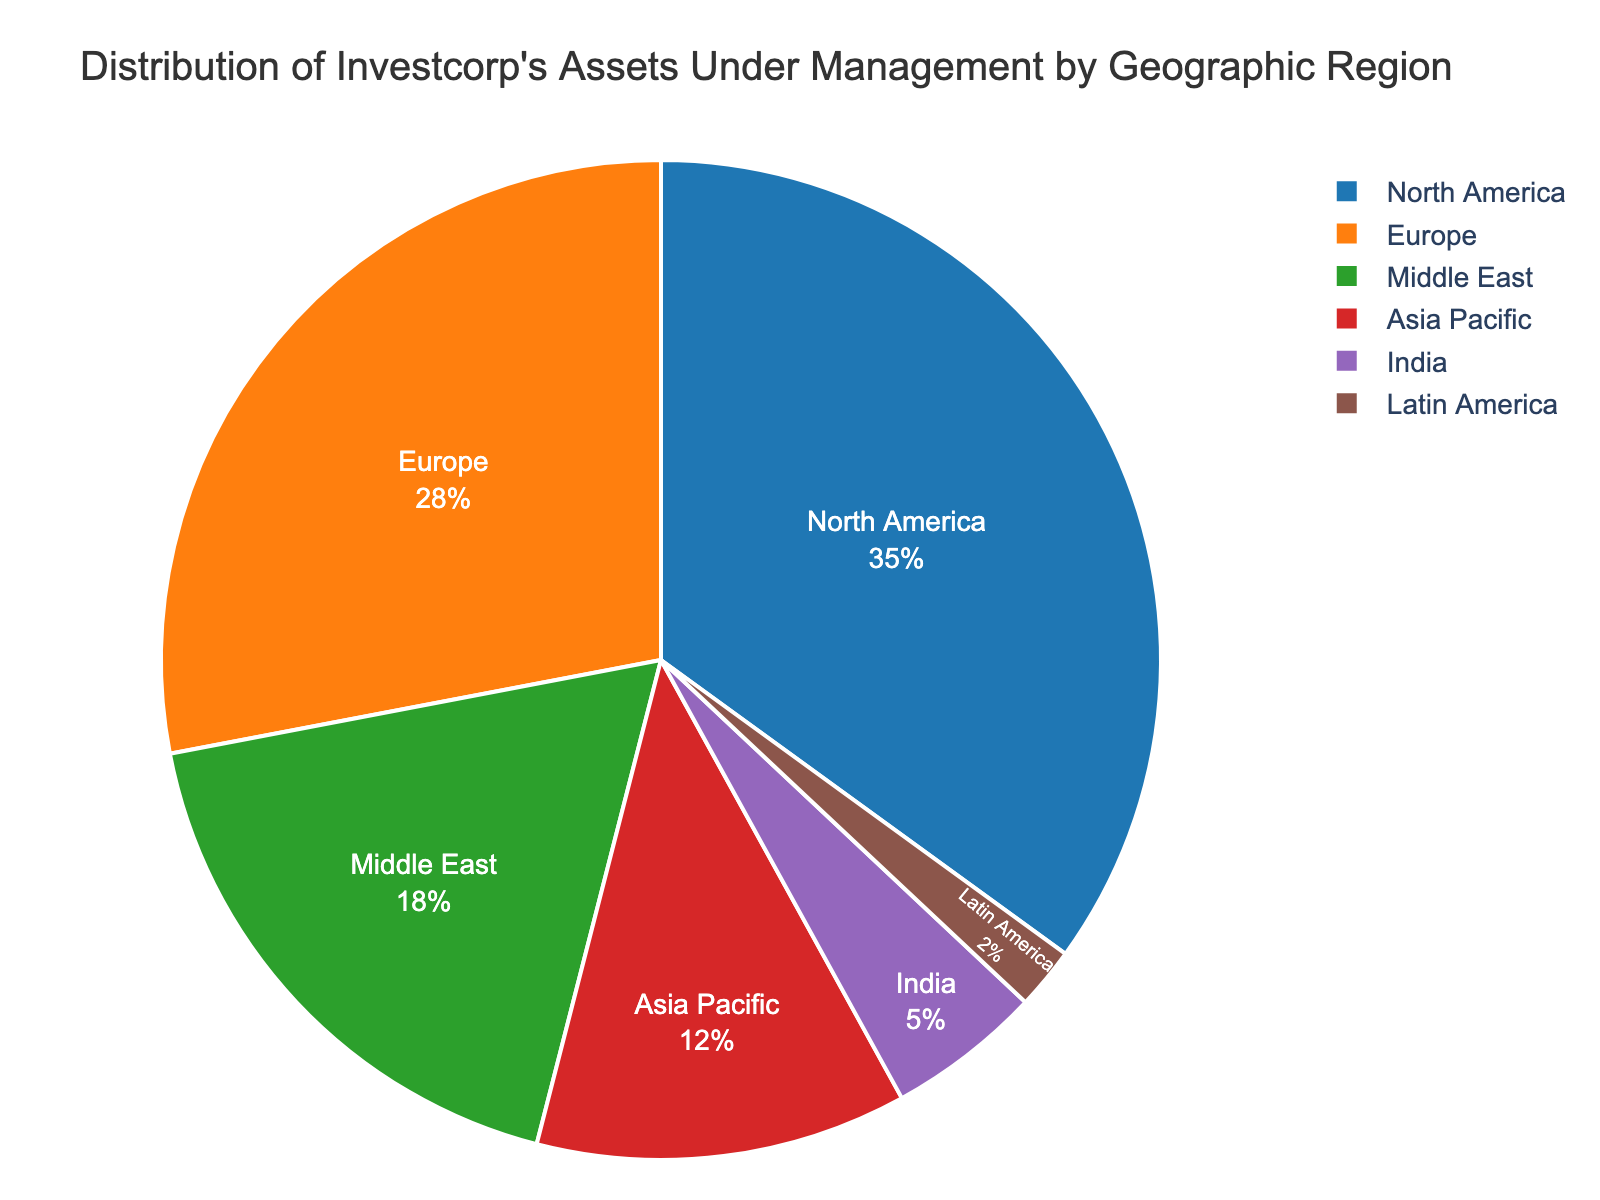Which region holds the largest percentage of Investcorp's assets under management? The figure shows the percentages of assets managed by region. North America holds the largest slice.
Answer: North America What is the combined percentage of Investcorp's assets under management in Asia Pacific and India? The figure indicates that Asia Pacific has 12% and India has 5%. Adding them gives 12% + 5% = 17%.
Answer: 17% Which region has the smallest percentage of Investcorp's assets under management? The smallest slice in the pie chart is labeled Latin America with 2%.
Answer: Latin America How much larger is the percentage of Investcorp's assets under management in Europe compared to the Middle East? Europe has 28% and the Middle East has 18%. The difference is 28% - 18% = 10%.
Answer: 10% If you add the percentages of Investcorp's assets under management in Europe and North America, what percentage do you get? Europe has 28% and North America has 35%. Adding them gives 28% + 35% = 63%.
Answer: 63% What percentage of Investcorp's assets under management is in regions outside North America, Europe, and the Middle East? North America, Europe, and the Middle East have a combined percentage of 35% + 28% + 18% = 81%. Subtracting from 100% gives 100% - 81% = 19%.
Answer: 19% Which region has a higher percentage of Investcorp's assets under management, Asia Pacific or India? By how much? Asia Pacific has 12% and India has 5%. The difference is 12% - 5% = 7%.
Answer: Asia Pacific, by 7% What percentage of Investcorp's assets under management is distributed in regions outside the Asia Pacific and Latin America? Asia Pacific and Latin America combined have 12% + 2% = 14%. Subtracting from 100% gives 100% - 14% = 86%.
Answer: 86% Which two regions together account for more than half of Investcorp's assets under management? North America has 35% and Europe has 28%. Adding them gives 35% + 28% = 63%, which is more than half.
Answer: North America and Europe 